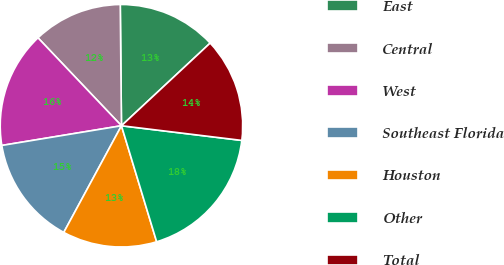<chart> <loc_0><loc_0><loc_500><loc_500><pie_chart><fcel>East<fcel>Central<fcel>West<fcel>Southeast Florida<fcel>Houston<fcel>Other<fcel>Total<nl><fcel>13.22%<fcel>11.93%<fcel>15.51%<fcel>14.51%<fcel>12.58%<fcel>18.38%<fcel>13.87%<nl></chart> 